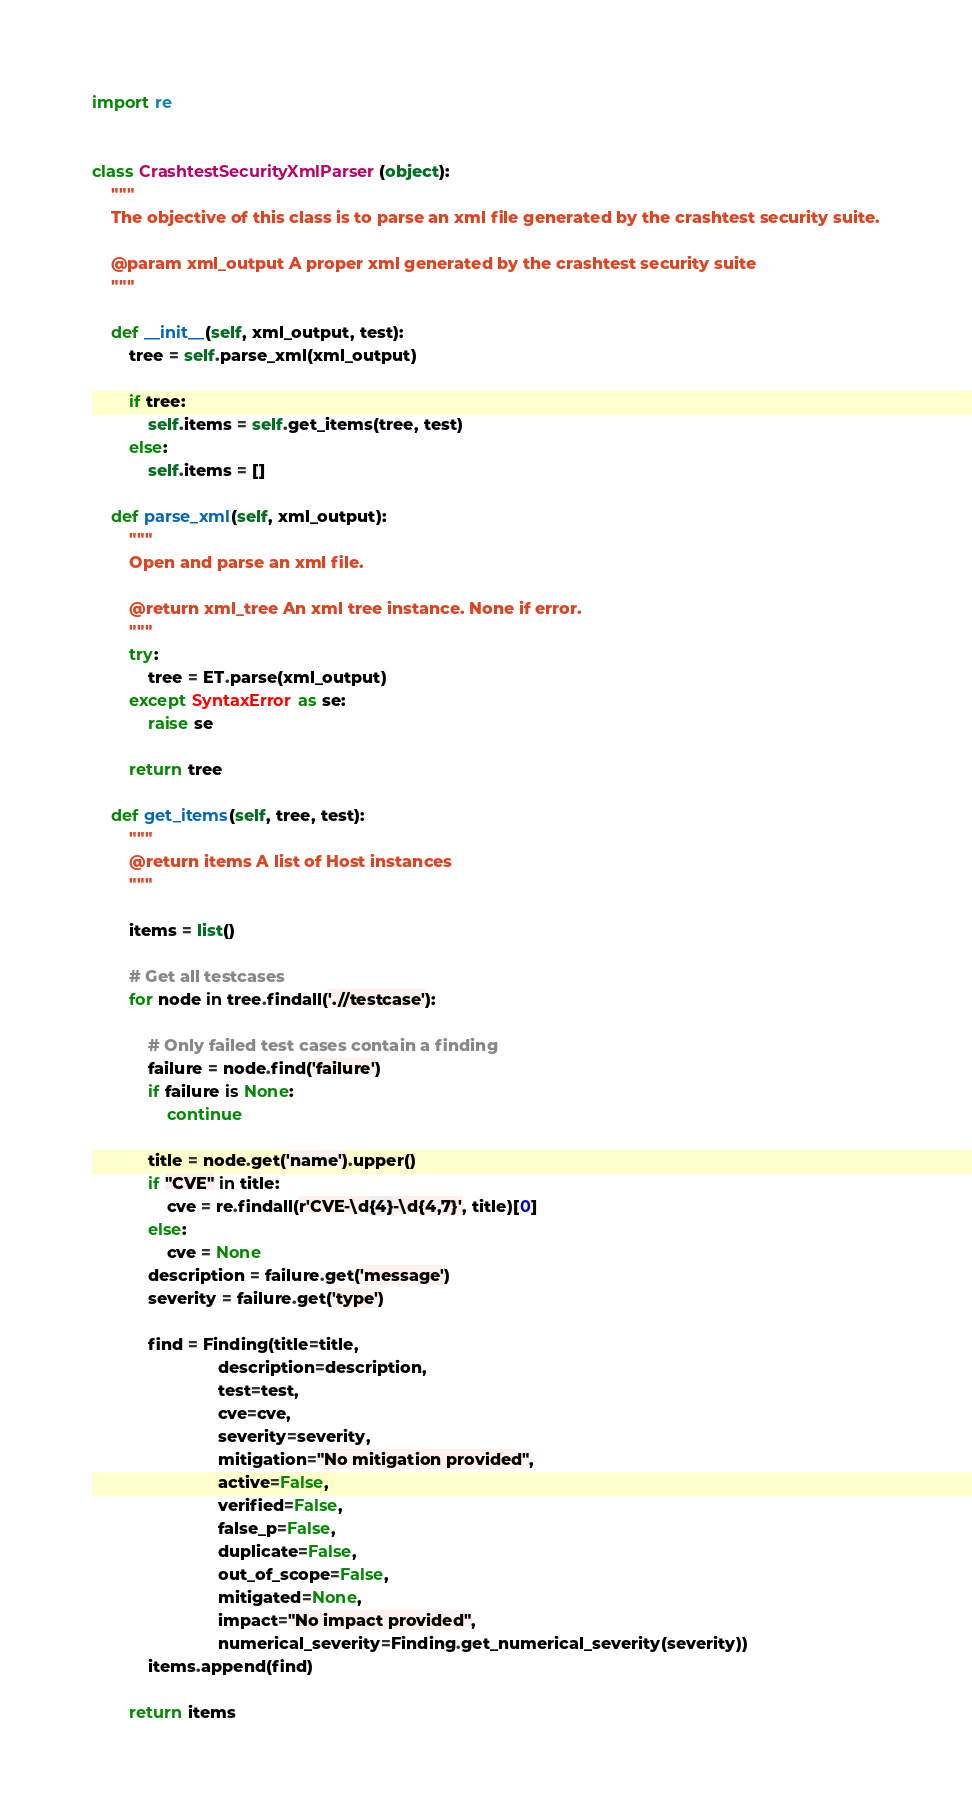Convert code to text. <code><loc_0><loc_0><loc_500><loc_500><_Python_>import re


class CrashtestSecurityXmlParser(object):
    """
    The objective of this class is to parse an xml file generated by the crashtest security suite.

    @param xml_output A proper xml generated by the crashtest security suite
    """

    def __init__(self, xml_output, test):
        tree = self.parse_xml(xml_output)

        if tree:
            self.items = self.get_items(tree, test)
        else:
            self.items = []

    def parse_xml(self, xml_output):
        """
        Open and parse an xml file.

        @return xml_tree An xml tree instance. None if error.
        """
        try:
            tree = ET.parse(xml_output)
        except SyntaxError as se:
            raise se

        return tree

    def get_items(self, tree, test):
        """
        @return items A list of Host instances
        """

        items = list()

        # Get all testcases
        for node in tree.findall('.//testcase'):

            # Only failed test cases contain a finding
            failure = node.find('failure')
            if failure is None:
                continue

            title = node.get('name').upper()
            if "CVE" in title:
                cve = re.findall(r'CVE-\d{4}-\d{4,7}', title)[0]
            else:
                cve = None
            description = failure.get('message')
            severity = failure.get('type')

            find = Finding(title=title,
                           description=description,
                           test=test,
                           cve=cve,
                           severity=severity,
                           mitigation="No mitigation provided",
                           active=False,
                           verified=False,
                           false_p=False,
                           duplicate=False,
                           out_of_scope=False,
                           mitigated=None,
                           impact="No impact provided",
                           numerical_severity=Finding.get_numerical_severity(severity))
            items.append(find)

        return items
</code> 